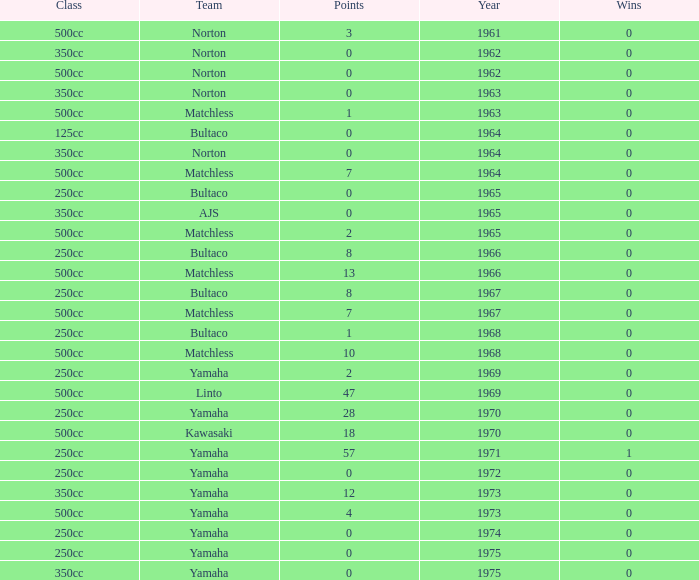What is the average wins in 250cc class for Bultaco with 8 points later than 1966? 0.0. 